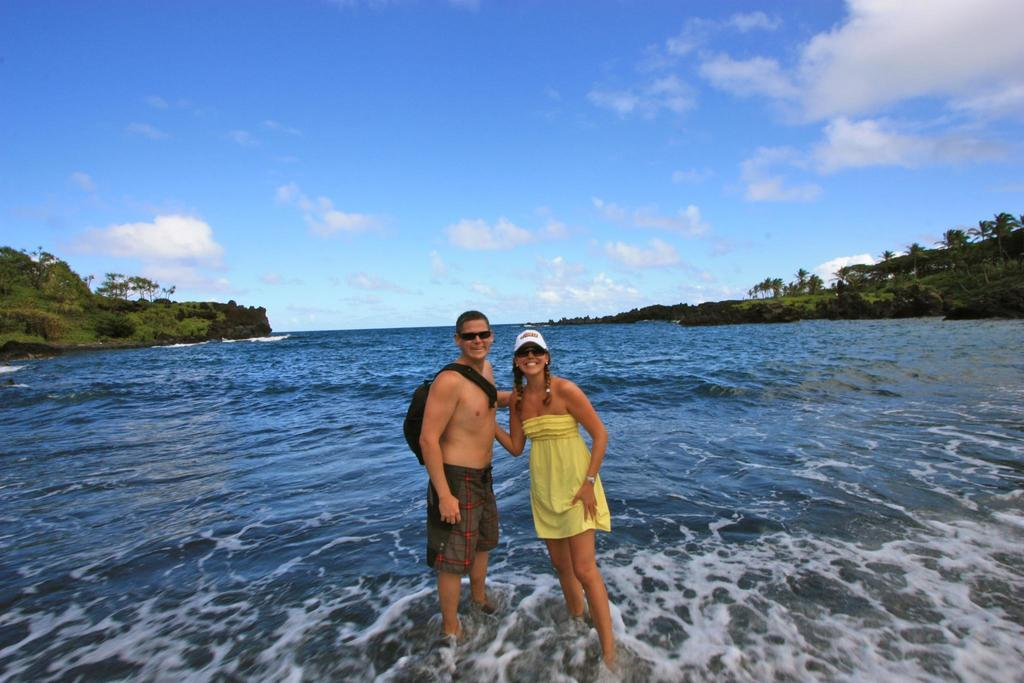What types of people are in the image? There are men and women in the image. Where are the people located in the image? They are standing at the seashore. What can be seen on either side of the sea? There are trees on either side of the sea. What is the color of the sky in the image? The sky is blue and visible at the top of the image. How does the control panel on the seashore affect the people in the image? There is no control panel present in the image; it features men and women standing at the seashore with trees on either side of the sea. What type of wound can be seen on the woman's leg in the image? There is no wound visible on any person's leg in the image. 